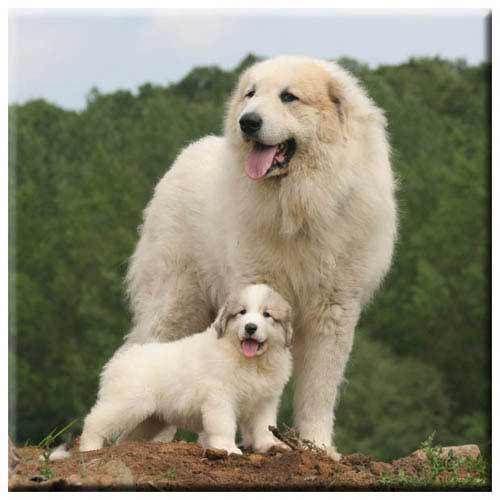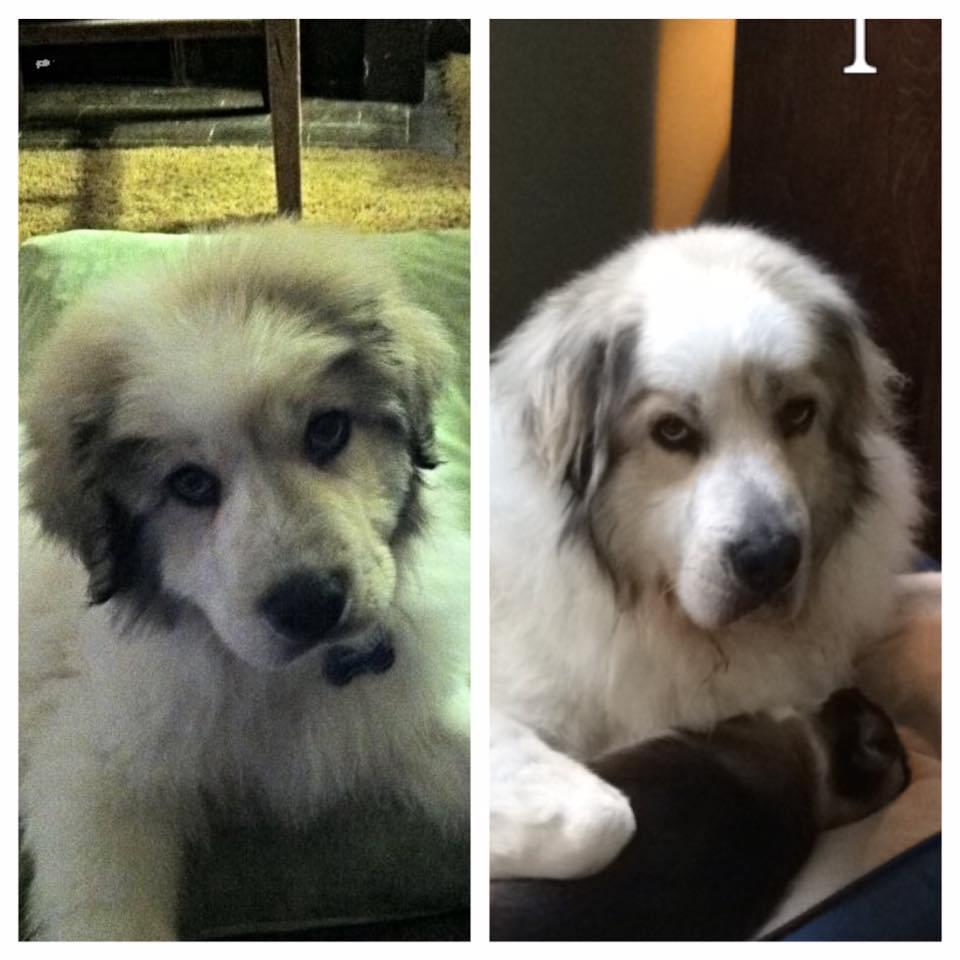The first image is the image on the left, the second image is the image on the right. Assess this claim about the two images: "Left image shows two dogs posed together outdoors.". Correct or not? Answer yes or no. Yes. 